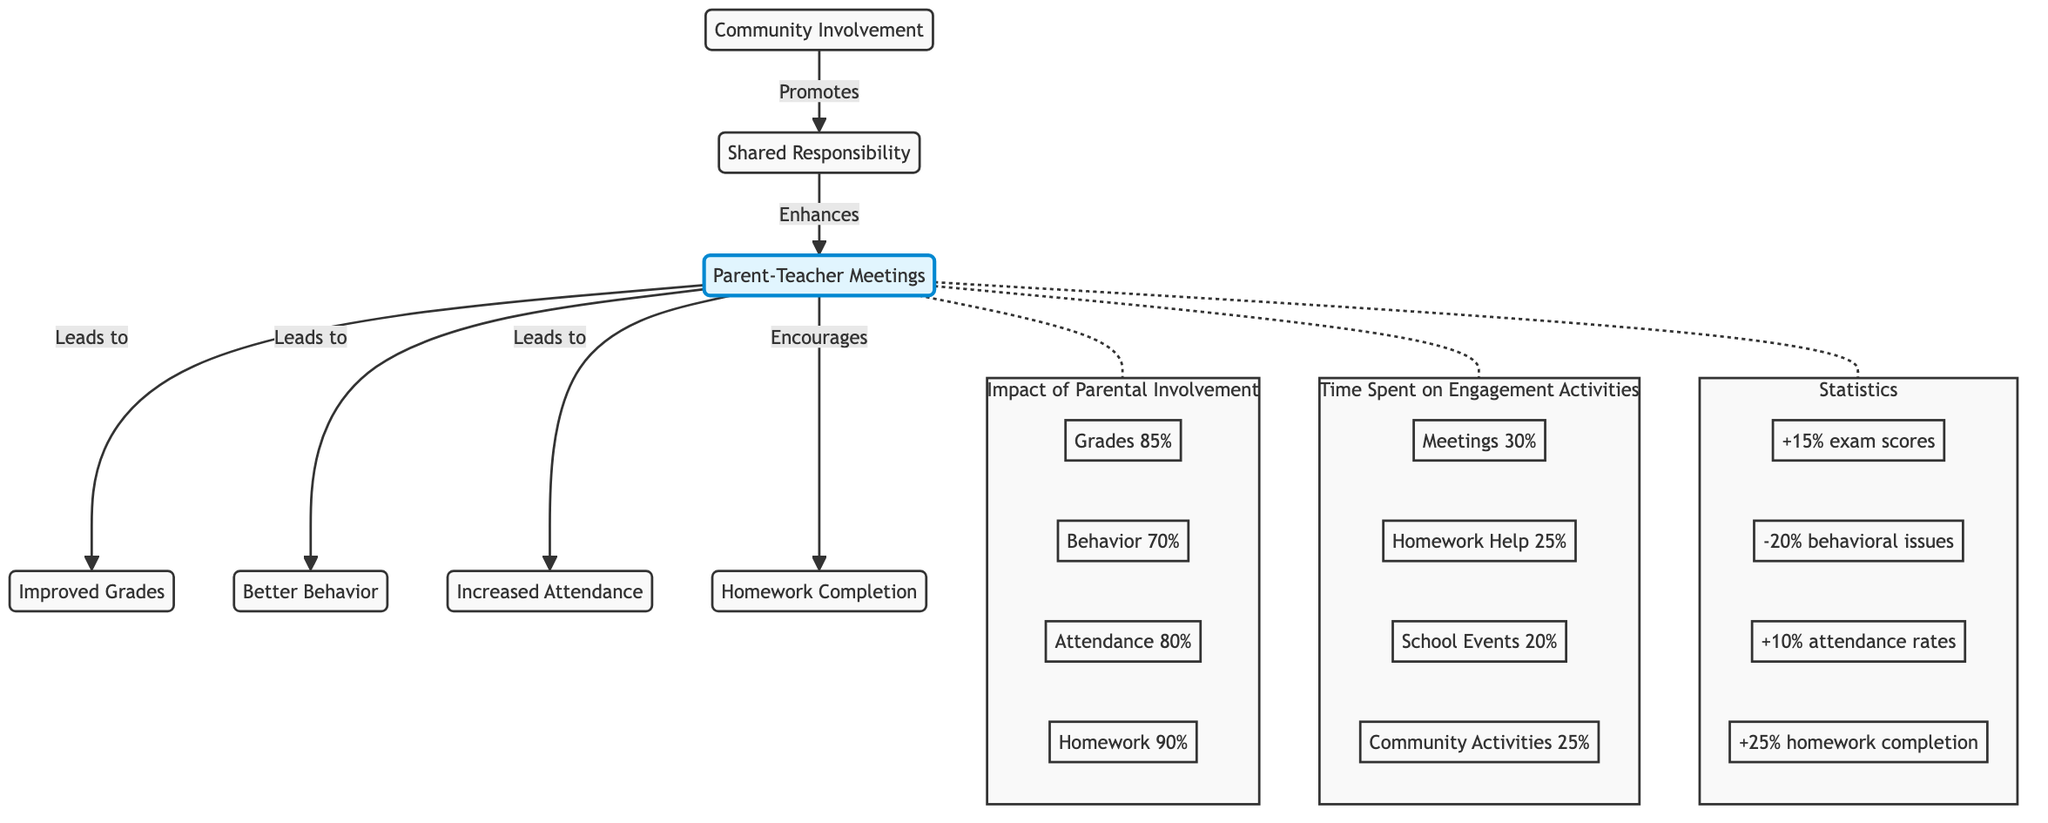What is the main benefit depicted in the diagram from Parent-Teacher Meetings? The diagram clearly shows that the main benefit is Improved Grades, as indicated by the direct path from Parent-Teacher Meetings to Improved Grades.
Answer: Improved Grades How many impacts are directly linked to Parent-Teacher Meetings? By counting the arrows pointing from Parent-Teacher Meetings, I note there are four distinct impacts: Improved Grades, Better Behavior, Increased Attendance, and Homework Completion.
Answer: Four What percentage of students showed improved homework completion? The diagram states that homework completion increased by 25%, indicating a significant improvement in this area due to parental involvement.
Answer: 25% What does the Community Involvement lead to according to the diagram? Community Involvement leads to Shared Responsibility, as shown in the directed edge from Community Involvement to Shared Responsibility in the diagram.
Answer: Shared Responsibility What is the behavior improvement percentage indicated in the statistics section? The statistics section highlights a -20% reduction in behavioral issues, which is a direct measure of the effects of parental engagement.
Answer: -20% What is the time percentage allocated to Homework Help? The diagram explicitly states that 25% of the time spent on engagement activities is dedicated to Homework Help, indicating a commitment from parents in this area.
Answer: 25% Which two nodes are connected by a dotted line in the diagram? The dotted line connects Parent-Teacher Meetings and the Impact of Parental Involvement, indicating a less direct relationship or correlation between them.
Answer: Impact of Parental Involvement What improvement in exam scores is associated with Parent-Teacher Meetings? According to the statistics noted in the diagram, there is a +15% improvement in exam scores that can be attributed to effective parental engagement through meetings.
Answer: +15% How does Shared Responsibility influence Parent-Teacher Meetings in the diagram? Shared Responsibility enhances Parent-Teacher Meetings, as indicated by the directed edge flowing from Shared Responsibility back to Parent-Teacher Meetings, suggesting that responsibility fosters engagement.
Answer: Enhances 